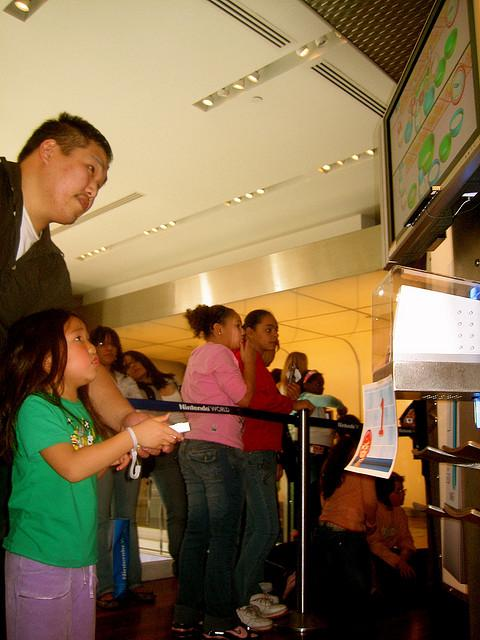What does the child hold in her hands? Please explain your reasoning. wii remote. It is a small white box and they are looking at a screen. 